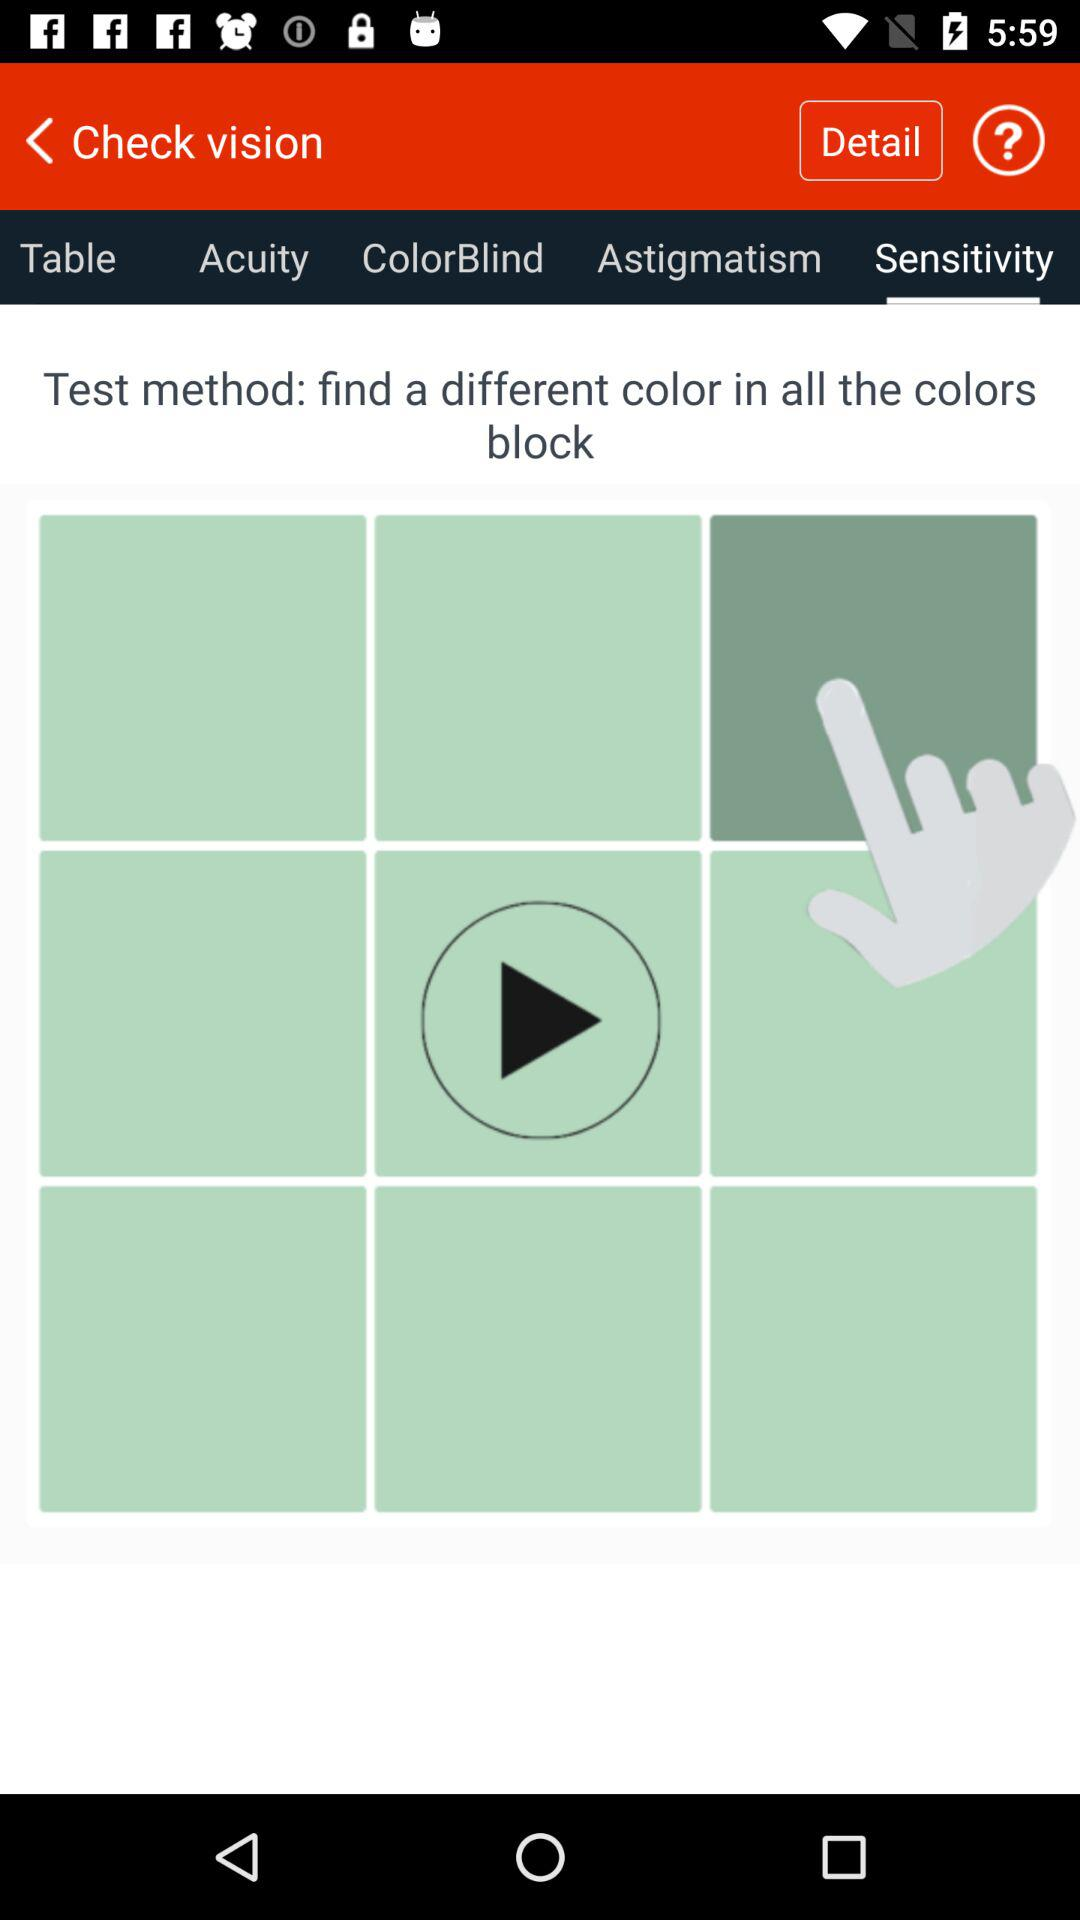What tab is selected? The selected tab is "Sensitivity". 